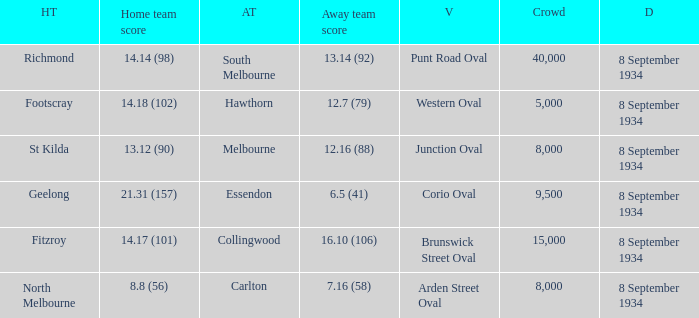When the Venue was Punt Road Oval, who was the Home Team? Richmond. 